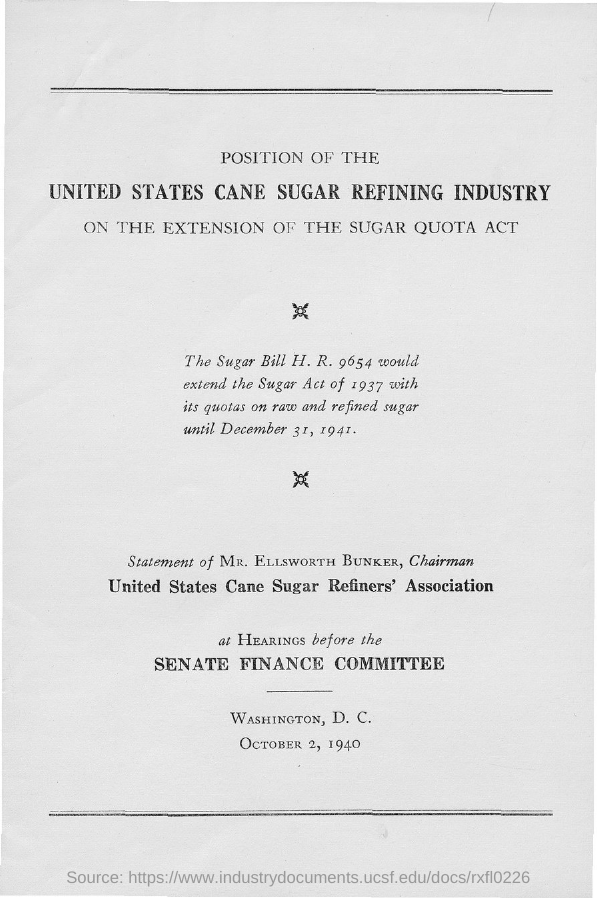Who is the Chairman of United States Cane Sugar Refiners' Association ?
Provide a succinct answer. MR. ELLSWORTH BUNKER. Which act is extended by "The sugar Bill H.R .9654"?
Make the answer very short. Sugar Act of 1937. 